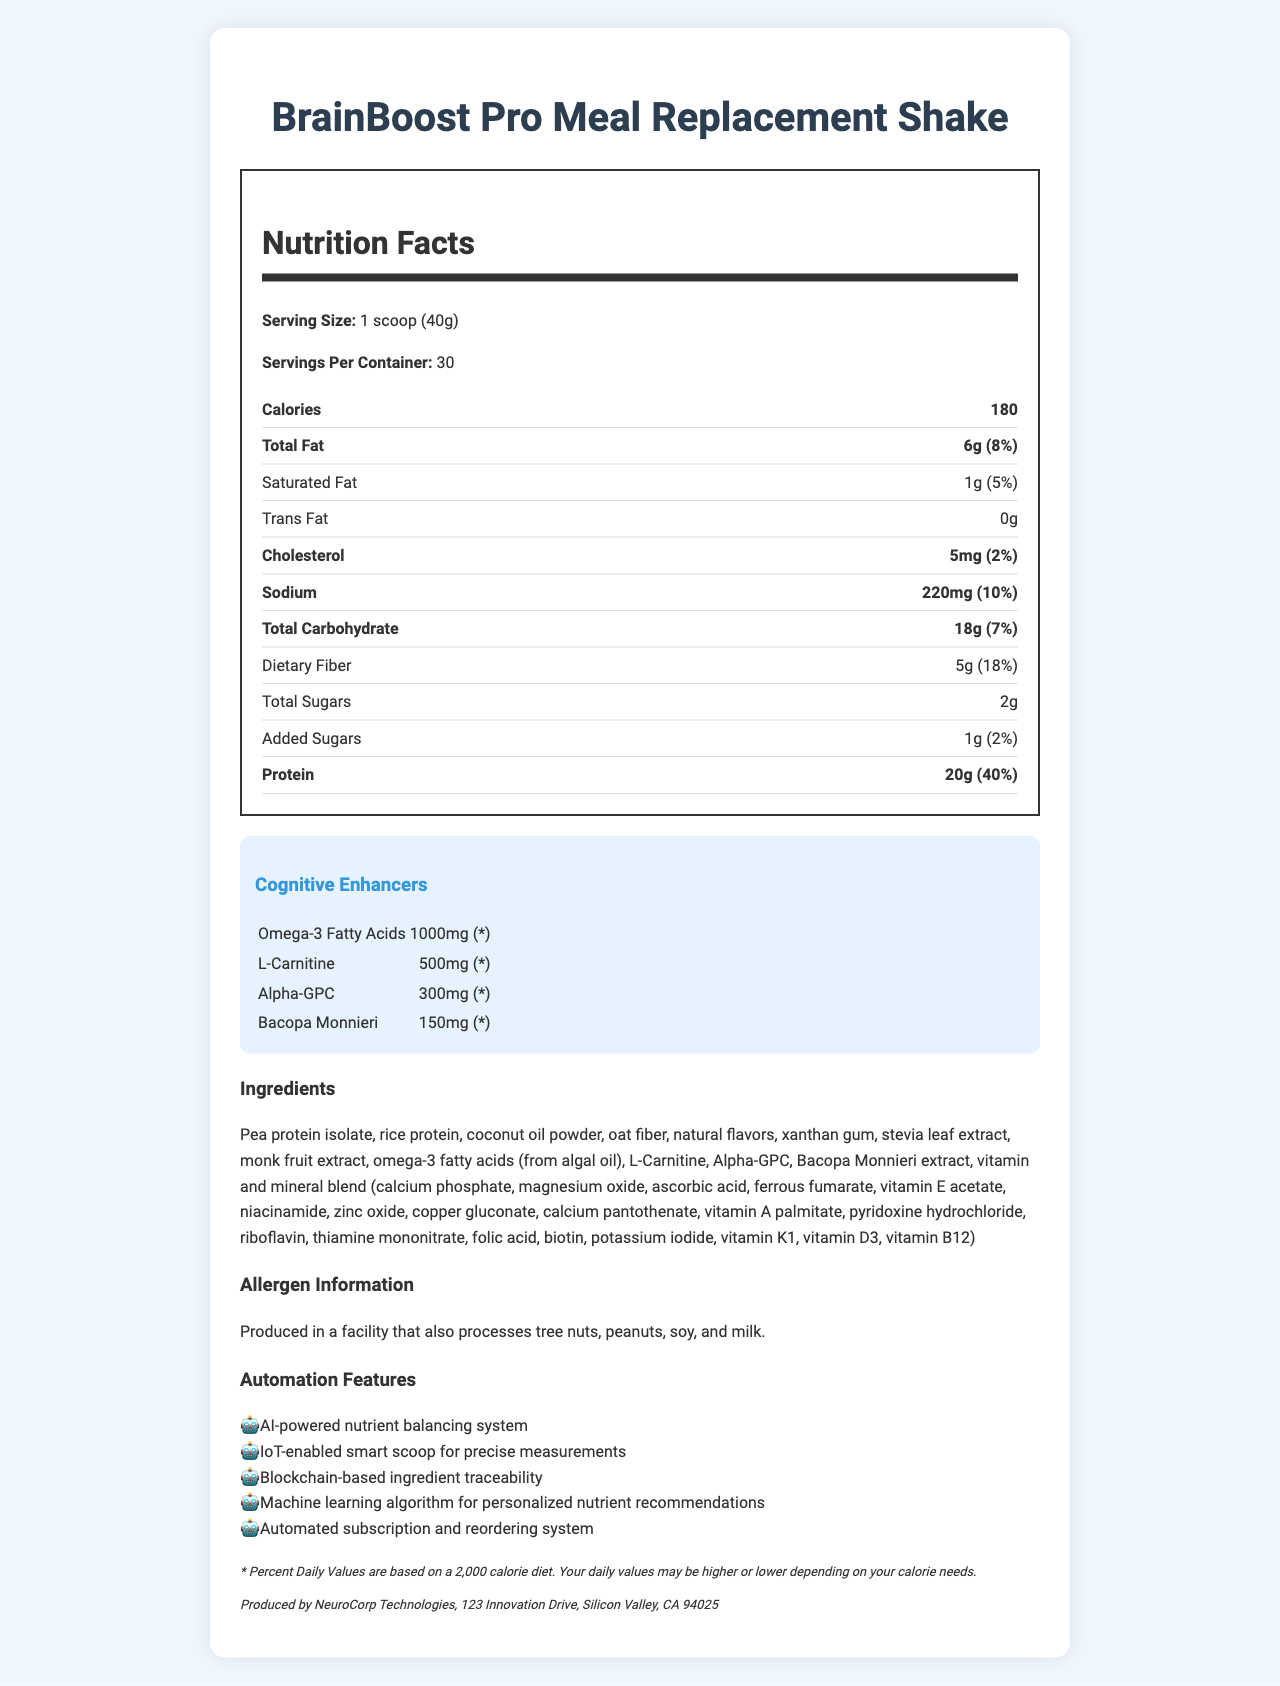what is the product name? The product name is clearly stated at the top of the document.
Answer: BrainBoost Pro Meal Replacement Shake what is the serving size of the product? The serving size is listed right below the product name in the nutrition facts.
Answer: 1 scoop (40g) how many calories are in one serving? The number of calories per serving is listed within the nutrition facts section.
Answer: 180 how much protein does one serving contain? The amount of protein per serving is provided in the nutrition facts section.
Answer: 20g what is the main benefit of the cognitive enhancers in this product? The product description mentions that it is designed to optimize cognitive performance.
Answer: To optimize cognitive performance what percentage of the daily value of Vitamin B12 does one serving contain? The daily value for Vitamin B12 is provided in the nutrition facts.
Answer: 250% which cognitive enhancer is present in the highest amount? A. Omega-3 Fatty Acids B. L-Carnitine C. Alpha-GPC D. Bacopa Monnieri The amount of cognitive enhancers is listed, and Omega-3 Fatty Acids has the highest amount at 1000mg.
Answer: A. Omega-3 Fatty Acids which of the following is an automation feature of the product? A. AI-powered nutrient balancing system B. VR-compatible C. Voice-controlled The listed automation features include an AI-powered nutrient balancing system.
Answer: A. AI-powered nutrient balancing system is this product produced in a facility that processes milk? The allergen information indicates that it is produced in a facility that processes milk.
Answer: Yes what type of fats are listed in the nutrition label? The nutrition label specifically lists these three types of fats.
Answer: Total Fat, Saturated Fat, Trans Fat summarize the main points of the document. The document aims to present comprehensive nutritional information and highlight the product's cognitive enhancements and advanced features.
Answer: The document provides the nutrition facts for BrainBoost Pro Meal Replacement Shake, emphasizing its cognitive enhancers, nutrition content, ingredients, allergen information, and automation features. what are the exact amounts of Vitamin D and Iron in one serving? The nutrition facts section lists these specific amounts for Vitamin D and Iron.
Answer: Vitamin D: 2mcg, Iron: 3.6mg how many servings are in one container? The servings per container value is listed in the nutrition facts section.
Answer: 30 how much sodium does one serving contain? The amount of sodium per serving is specified in the nutrition facts section.
Answer: 220mg what percentage of the daily value of dietary fiber does one serving contain? The daily value of dietary fiber per serving is listed in the nutrition facts.
Answer: 18% what is the daily value percentage of cholesterol per serving? The daily value percentage for cholesterol is provided in the nutrition facts section.
Answer: 2% what is the allergen information for this product? The allergen information is clearly mentioned under the allergen info section.
Answer: Produced in a facility that also processes tree nuts, peanuts, soy, and milk. how much total carbohydrates are there in one serving? The total carbohydrate content is specified in the nutrition facts section.
Answer: 18g how much Vitamin C is in one serving in terms of daily value percentage? The daily value percentage for Vitamin C is listed in the nutrition facts.
Answer: 67% how many grams of total sugars are in one serving? The total sugars content per serving is provided in the nutrition facts section.
Answer: 2g what are the primary ingredients of this product? The list of primary ingredients is detailed in the ingredients section.
Answer: Pea protein isolate, rice protein, coconut oil powder, oat fiber, natural flavors, and more what is the manufacturer address of this product? The manufacturer information is listed at the bottom of the document.
Answer: 123 Innovation Drive, Silicon Valley, CA 94025 how often is the blockchain used in the product's automation features? The document lists blockchain-based ingredient traceability as one of the automation features but does not mention the frequency of use.
Answer: Cannot be determined 